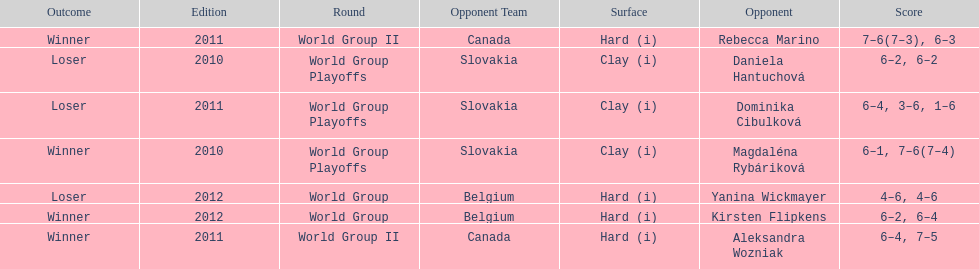Was the game versus canada later than the game versus belgium? No. 